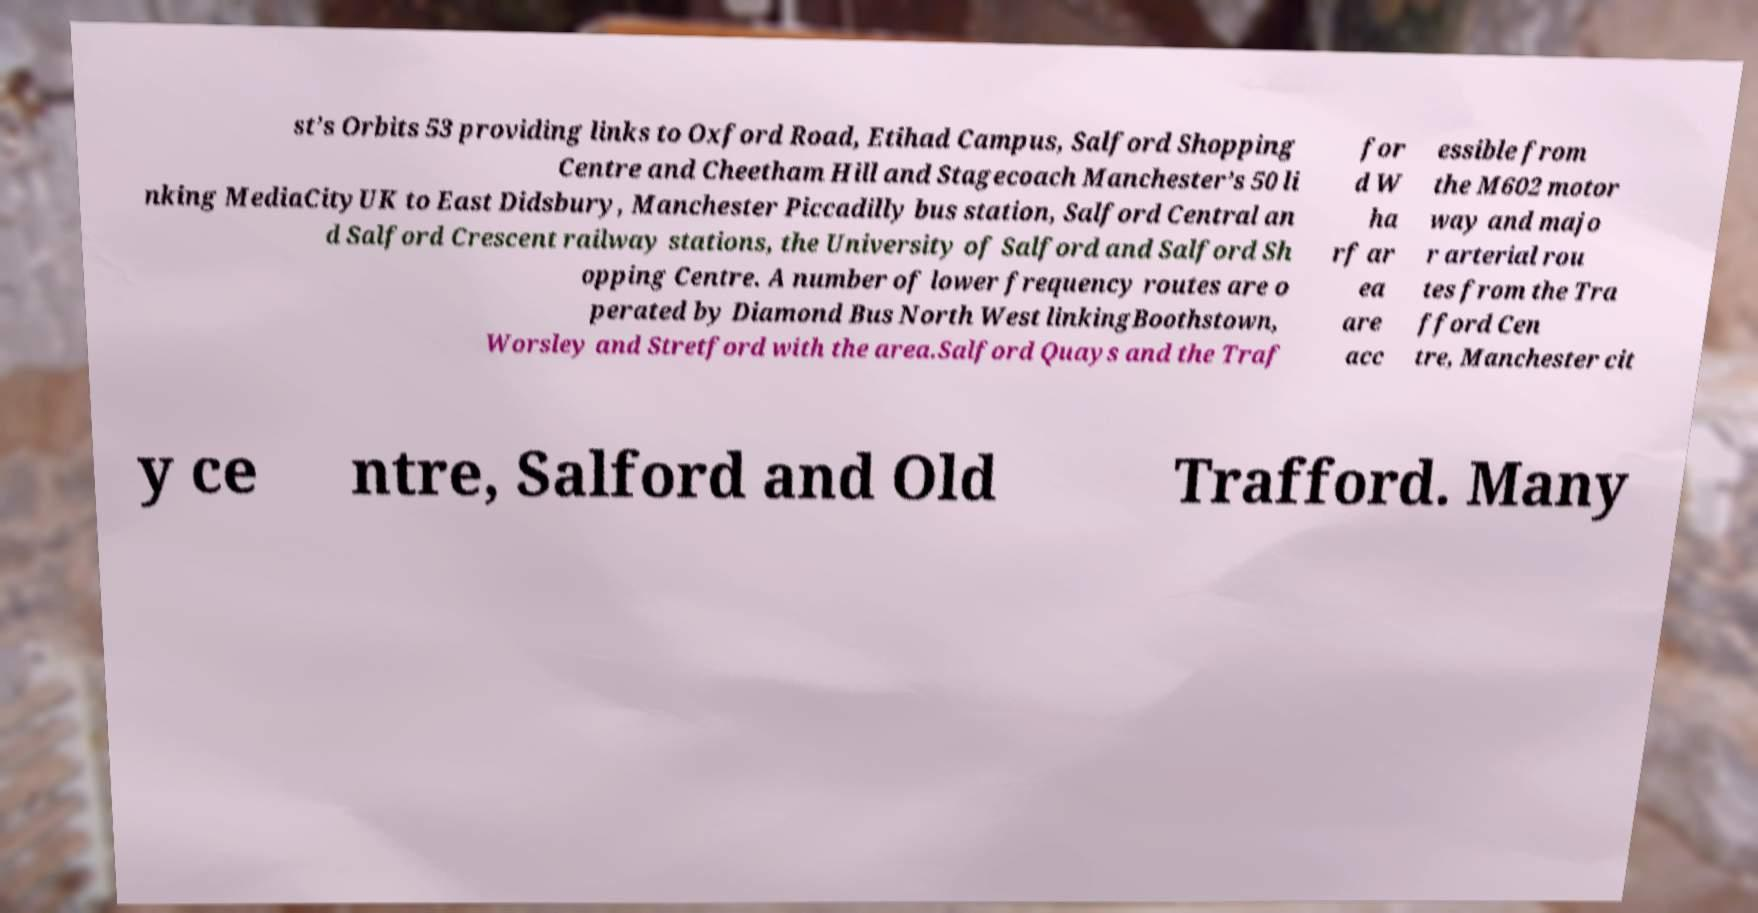Please read and relay the text visible in this image. What does it say? st’s Orbits 53 providing links to Oxford Road, Etihad Campus, Salford Shopping Centre and Cheetham Hill and Stagecoach Manchester’s 50 li nking MediaCityUK to East Didsbury, Manchester Piccadilly bus station, Salford Central an d Salford Crescent railway stations, the University of Salford and Salford Sh opping Centre. A number of lower frequency routes are o perated by Diamond Bus North West linkingBoothstown, Worsley and Stretford with the area.Salford Quays and the Traf for d W ha rf ar ea are acc essible from the M602 motor way and majo r arterial rou tes from the Tra fford Cen tre, Manchester cit y ce ntre, Salford and Old Trafford. Many 